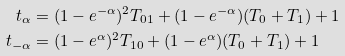<formula> <loc_0><loc_0><loc_500><loc_500>t _ { \alpha } & = ( 1 - e ^ { - \alpha } ) ^ { 2 } T _ { 0 1 } + ( 1 - e ^ { - \alpha } ) ( T _ { 0 } + T _ { 1 } ) + 1 \\ t _ { - \alpha } & = ( 1 - e ^ { \alpha } ) ^ { 2 } T _ { 1 0 } + ( 1 - e ^ { \alpha } ) ( T _ { 0 } + T _ { 1 } ) + 1</formula> 